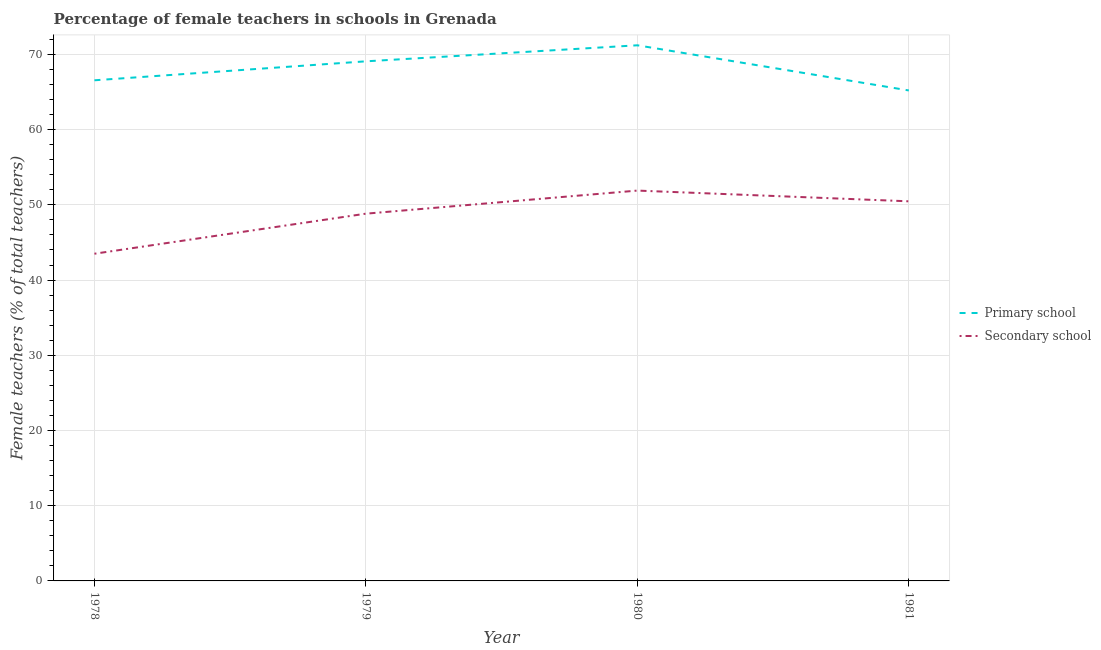Does the line corresponding to percentage of female teachers in primary schools intersect with the line corresponding to percentage of female teachers in secondary schools?
Your response must be concise. No. Is the number of lines equal to the number of legend labels?
Ensure brevity in your answer.  Yes. What is the percentage of female teachers in primary schools in 1978?
Your answer should be compact. 66.56. Across all years, what is the maximum percentage of female teachers in primary schools?
Your response must be concise. 71.21. Across all years, what is the minimum percentage of female teachers in primary schools?
Your answer should be very brief. 65.21. In which year was the percentage of female teachers in primary schools maximum?
Give a very brief answer. 1980. What is the total percentage of female teachers in primary schools in the graph?
Ensure brevity in your answer.  272.05. What is the difference between the percentage of female teachers in primary schools in 1980 and that in 1981?
Your answer should be compact. 6. What is the difference between the percentage of female teachers in primary schools in 1978 and the percentage of female teachers in secondary schools in 1980?
Your response must be concise. 14.66. What is the average percentage of female teachers in secondary schools per year?
Give a very brief answer. 48.67. In the year 1980, what is the difference between the percentage of female teachers in primary schools and percentage of female teachers in secondary schools?
Your response must be concise. 19.32. In how many years, is the percentage of female teachers in secondary schools greater than 70 %?
Keep it short and to the point. 0. What is the ratio of the percentage of female teachers in secondary schools in 1978 to that in 1979?
Ensure brevity in your answer.  0.89. Is the percentage of female teachers in primary schools in 1979 less than that in 1981?
Your answer should be very brief. No. What is the difference between the highest and the second highest percentage of female teachers in secondary schools?
Offer a terse response. 1.43. What is the difference between the highest and the lowest percentage of female teachers in secondary schools?
Your response must be concise. 8.4. Is the sum of the percentage of female teachers in primary schools in 1978 and 1981 greater than the maximum percentage of female teachers in secondary schools across all years?
Keep it short and to the point. Yes. Does the percentage of female teachers in secondary schools monotonically increase over the years?
Offer a very short reply. No. Is the percentage of female teachers in secondary schools strictly greater than the percentage of female teachers in primary schools over the years?
Offer a terse response. No. Is the percentage of female teachers in primary schools strictly less than the percentage of female teachers in secondary schools over the years?
Provide a short and direct response. No. How many lines are there?
Your response must be concise. 2. What is the difference between two consecutive major ticks on the Y-axis?
Keep it short and to the point. 10. Does the graph contain grids?
Give a very brief answer. Yes. How are the legend labels stacked?
Keep it short and to the point. Vertical. What is the title of the graph?
Your answer should be very brief. Percentage of female teachers in schools in Grenada. Does "Under five" appear as one of the legend labels in the graph?
Provide a short and direct response. No. What is the label or title of the Y-axis?
Offer a terse response. Female teachers (% of total teachers). What is the Female teachers (% of total teachers) in Primary school in 1978?
Make the answer very short. 66.56. What is the Female teachers (% of total teachers) of Secondary school in 1978?
Your response must be concise. 43.5. What is the Female teachers (% of total teachers) in Primary school in 1979?
Give a very brief answer. 69.08. What is the Female teachers (% of total teachers) of Secondary school in 1979?
Ensure brevity in your answer.  48.83. What is the Female teachers (% of total teachers) in Primary school in 1980?
Ensure brevity in your answer.  71.21. What is the Female teachers (% of total teachers) of Secondary school in 1980?
Provide a short and direct response. 51.89. What is the Female teachers (% of total teachers) in Primary school in 1981?
Provide a succinct answer. 65.21. What is the Female teachers (% of total teachers) of Secondary school in 1981?
Your answer should be very brief. 50.47. Across all years, what is the maximum Female teachers (% of total teachers) of Primary school?
Your answer should be very brief. 71.21. Across all years, what is the maximum Female teachers (% of total teachers) of Secondary school?
Provide a succinct answer. 51.89. Across all years, what is the minimum Female teachers (% of total teachers) of Primary school?
Keep it short and to the point. 65.21. Across all years, what is the minimum Female teachers (% of total teachers) of Secondary school?
Offer a terse response. 43.5. What is the total Female teachers (% of total teachers) in Primary school in the graph?
Provide a succinct answer. 272.05. What is the total Female teachers (% of total teachers) of Secondary school in the graph?
Keep it short and to the point. 194.69. What is the difference between the Female teachers (% of total teachers) of Primary school in 1978 and that in 1979?
Offer a terse response. -2.52. What is the difference between the Female teachers (% of total teachers) of Secondary school in 1978 and that in 1979?
Provide a succinct answer. -5.33. What is the difference between the Female teachers (% of total teachers) in Primary school in 1978 and that in 1980?
Offer a terse response. -4.65. What is the difference between the Female teachers (% of total teachers) in Secondary school in 1978 and that in 1980?
Offer a terse response. -8.4. What is the difference between the Female teachers (% of total teachers) of Primary school in 1978 and that in 1981?
Keep it short and to the point. 1.35. What is the difference between the Female teachers (% of total teachers) in Secondary school in 1978 and that in 1981?
Your response must be concise. -6.97. What is the difference between the Female teachers (% of total teachers) in Primary school in 1979 and that in 1980?
Provide a short and direct response. -2.13. What is the difference between the Female teachers (% of total teachers) in Secondary school in 1979 and that in 1980?
Offer a terse response. -3.07. What is the difference between the Female teachers (% of total teachers) in Primary school in 1979 and that in 1981?
Your answer should be compact. 3.87. What is the difference between the Female teachers (% of total teachers) of Secondary school in 1979 and that in 1981?
Make the answer very short. -1.64. What is the difference between the Female teachers (% of total teachers) of Primary school in 1980 and that in 1981?
Provide a short and direct response. 6. What is the difference between the Female teachers (% of total teachers) in Secondary school in 1980 and that in 1981?
Your answer should be compact. 1.43. What is the difference between the Female teachers (% of total teachers) of Primary school in 1978 and the Female teachers (% of total teachers) of Secondary school in 1979?
Offer a very short reply. 17.73. What is the difference between the Female teachers (% of total teachers) of Primary school in 1978 and the Female teachers (% of total teachers) of Secondary school in 1980?
Keep it short and to the point. 14.66. What is the difference between the Female teachers (% of total teachers) in Primary school in 1978 and the Female teachers (% of total teachers) in Secondary school in 1981?
Ensure brevity in your answer.  16.09. What is the difference between the Female teachers (% of total teachers) of Primary school in 1979 and the Female teachers (% of total teachers) of Secondary school in 1980?
Keep it short and to the point. 17.18. What is the difference between the Female teachers (% of total teachers) in Primary school in 1979 and the Female teachers (% of total teachers) in Secondary school in 1981?
Keep it short and to the point. 18.61. What is the difference between the Female teachers (% of total teachers) of Primary school in 1980 and the Female teachers (% of total teachers) of Secondary school in 1981?
Provide a succinct answer. 20.74. What is the average Female teachers (% of total teachers) of Primary school per year?
Your answer should be compact. 68.01. What is the average Female teachers (% of total teachers) in Secondary school per year?
Offer a terse response. 48.67. In the year 1978, what is the difference between the Female teachers (% of total teachers) of Primary school and Female teachers (% of total teachers) of Secondary school?
Offer a terse response. 23.06. In the year 1979, what is the difference between the Female teachers (% of total teachers) of Primary school and Female teachers (% of total teachers) of Secondary school?
Your answer should be compact. 20.25. In the year 1980, what is the difference between the Female teachers (% of total teachers) in Primary school and Female teachers (% of total teachers) in Secondary school?
Provide a short and direct response. 19.32. In the year 1981, what is the difference between the Female teachers (% of total teachers) in Primary school and Female teachers (% of total teachers) in Secondary school?
Provide a succinct answer. 14.74. What is the ratio of the Female teachers (% of total teachers) of Primary school in 1978 to that in 1979?
Make the answer very short. 0.96. What is the ratio of the Female teachers (% of total teachers) in Secondary school in 1978 to that in 1979?
Provide a short and direct response. 0.89. What is the ratio of the Female teachers (% of total teachers) of Primary school in 1978 to that in 1980?
Provide a short and direct response. 0.93. What is the ratio of the Female teachers (% of total teachers) in Secondary school in 1978 to that in 1980?
Your answer should be compact. 0.84. What is the ratio of the Female teachers (% of total teachers) of Primary school in 1978 to that in 1981?
Your answer should be compact. 1.02. What is the ratio of the Female teachers (% of total teachers) in Secondary school in 1978 to that in 1981?
Offer a terse response. 0.86. What is the ratio of the Female teachers (% of total teachers) of Primary school in 1979 to that in 1980?
Offer a very short reply. 0.97. What is the ratio of the Female teachers (% of total teachers) in Secondary school in 1979 to that in 1980?
Provide a short and direct response. 0.94. What is the ratio of the Female teachers (% of total teachers) in Primary school in 1979 to that in 1981?
Make the answer very short. 1.06. What is the ratio of the Female teachers (% of total teachers) of Secondary school in 1979 to that in 1981?
Provide a succinct answer. 0.97. What is the ratio of the Female teachers (% of total teachers) of Primary school in 1980 to that in 1981?
Give a very brief answer. 1.09. What is the ratio of the Female teachers (% of total teachers) of Secondary school in 1980 to that in 1981?
Your answer should be very brief. 1.03. What is the difference between the highest and the second highest Female teachers (% of total teachers) of Primary school?
Provide a succinct answer. 2.13. What is the difference between the highest and the second highest Female teachers (% of total teachers) in Secondary school?
Offer a very short reply. 1.43. What is the difference between the highest and the lowest Female teachers (% of total teachers) of Primary school?
Give a very brief answer. 6. What is the difference between the highest and the lowest Female teachers (% of total teachers) in Secondary school?
Give a very brief answer. 8.4. 